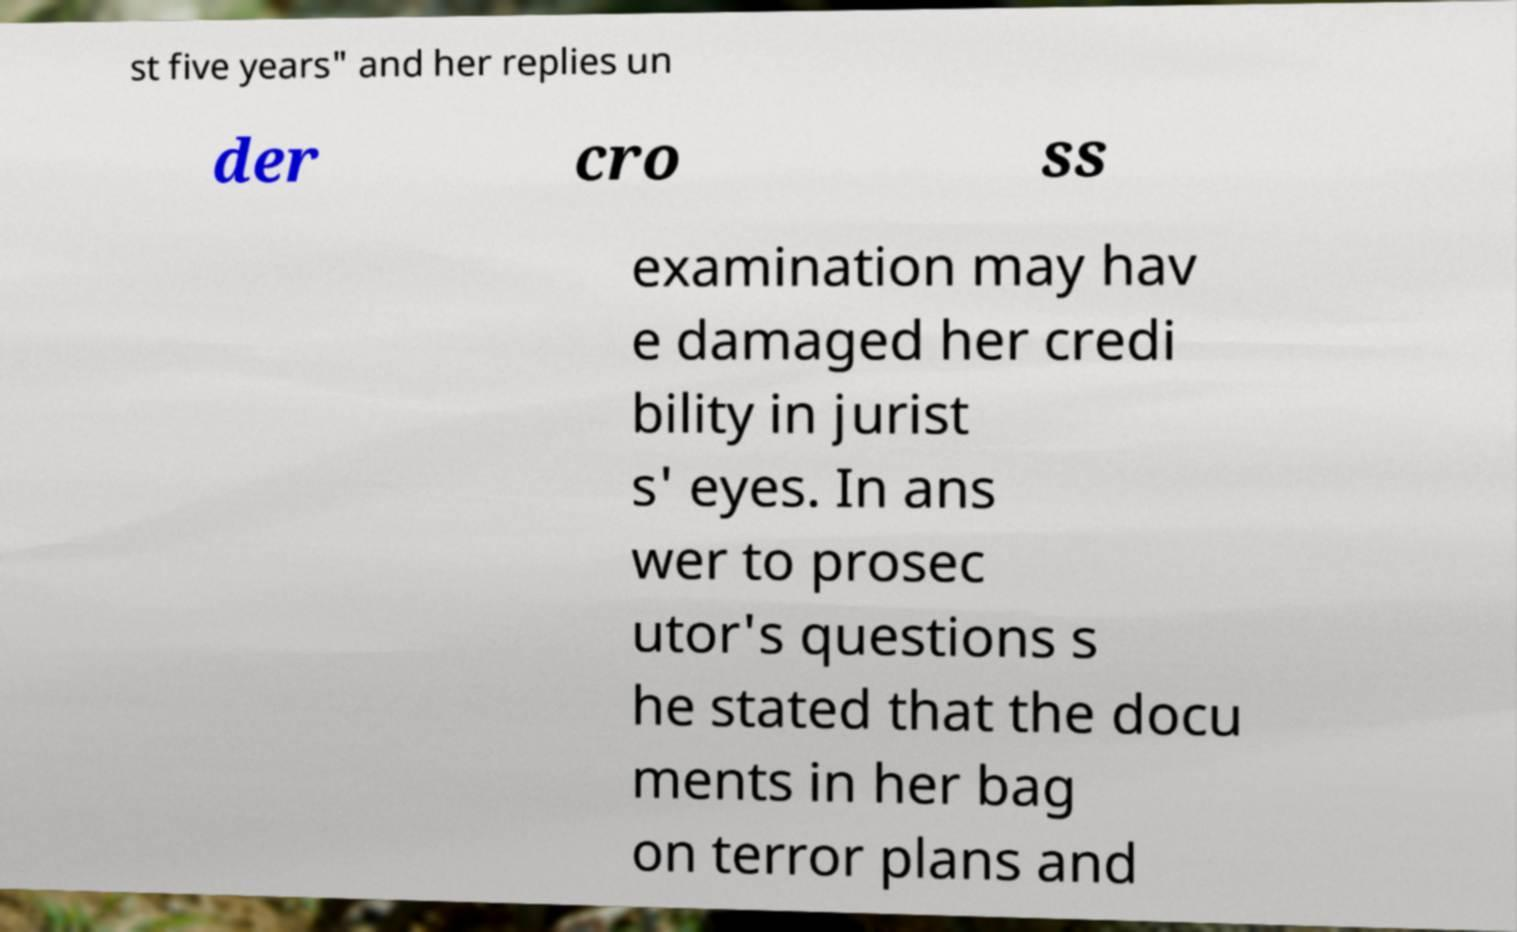Could you assist in decoding the text presented in this image and type it out clearly? st five years" and her replies un der cro ss examination may hav e damaged her credi bility in jurist s' eyes. In ans wer to prosec utor's questions s he stated that the docu ments in her bag on terror plans and 